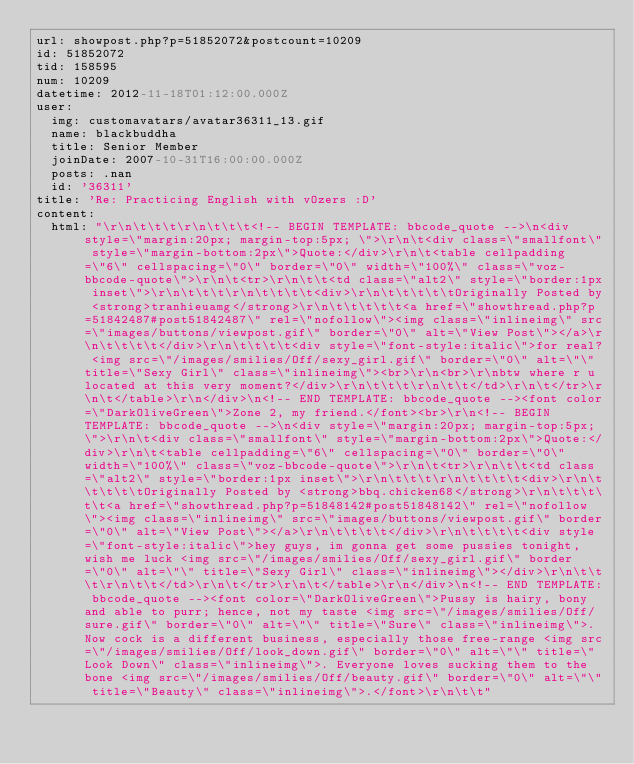<code> <loc_0><loc_0><loc_500><loc_500><_YAML_>url: showpost.php?p=51852072&postcount=10209
id: 51852072
tid: 158595
num: 10209
datetime: 2012-11-18T01:12:00.000Z
user:
  img: customavatars/avatar36311_13.gif
  name: blackbuddha
  title: Senior Member
  joinDate: 2007-10-31T16:00:00.000Z
  posts: .nan
  id: '36311'
title: 'Re: Practicing English with vOzers :D'
content:
  html: "\r\n\t\t\t\r\n\t\t\t<!-- BEGIN TEMPLATE: bbcode_quote -->\n<div style=\"margin:20px; margin-top:5px; \">\r\n\t<div class=\"smallfont\" style=\"margin-bottom:2px\">Quote:</div>\r\n\t<table cellpadding=\"6\" cellspacing=\"0\" border=\"0\" width=\"100%\" class=\"voz-bbcode-quote\">\r\n\t<tr>\r\n\t\t<td class=\"alt2\" style=\"border:1px inset\">\r\n\t\t\t\r\n\t\t\t\t<div>\r\n\t\t\t\t\tOriginally Posted by <strong>tranhieuamg</strong>\r\n\t\t\t\t\t<a href=\"showthread.php?p=51842487#post51842487\" rel=\"nofollow\"><img class=\"inlineimg\" src=\"images/buttons/viewpost.gif\" border=\"0\" alt=\"View Post\"></a>\r\n\t\t\t\t</div>\r\n\t\t\t\t<div style=\"font-style:italic\">for real? <img src=\"/images/smilies/Off/sexy_girl.gif\" border=\"0\" alt=\"\" title=\"Sexy Girl\" class=\"inlineimg\"><br>\r\n<br>\r\nbtw where r u located at this very moment?</div>\r\n\t\t\t\r\n\t\t</td>\r\n\t</tr>\r\n\t</table>\r\n</div>\n<!-- END TEMPLATE: bbcode_quote --><font color=\"DarkOliveGreen\">Zone 2, my friend.</font><br>\r\n<!-- BEGIN TEMPLATE: bbcode_quote -->\n<div style=\"margin:20px; margin-top:5px; \">\r\n\t<div class=\"smallfont\" style=\"margin-bottom:2px\">Quote:</div>\r\n\t<table cellpadding=\"6\" cellspacing=\"0\" border=\"0\" width=\"100%\" class=\"voz-bbcode-quote\">\r\n\t<tr>\r\n\t\t<td class=\"alt2\" style=\"border:1px inset\">\r\n\t\t\t\r\n\t\t\t\t<div>\r\n\t\t\t\t\tOriginally Posted by <strong>bbq.chicken68</strong>\r\n\t\t\t\t\t<a href=\"showthread.php?p=51848142#post51848142\" rel=\"nofollow\"><img class=\"inlineimg\" src=\"images/buttons/viewpost.gif\" border=\"0\" alt=\"View Post\"></a>\r\n\t\t\t\t</div>\r\n\t\t\t\t<div style=\"font-style:italic\">hey guys, im gonna get some pussies tonight, wish me luck <img src=\"/images/smilies/Off/sexy_girl.gif\" border=\"0\" alt=\"\" title=\"Sexy Girl\" class=\"inlineimg\"></div>\r\n\t\t\t\r\n\t\t</td>\r\n\t</tr>\r\n\t</table>\r\n</div>\n<!-- END TEMPLATE: bbcode_quote --><font color=\"DarkOliveGreen\">Pussy is hairy, bony and able to purr; hence, not my taste <img src=\"/images/smilies/Off/sure.gif\" border=\"0\" alt=\"\" title=\"Sure\" class=\"inlineimg\">. Now cock is a different business, especially those free-range <img src=\"/images/smilies/Off/look_down.gif\" border=\"0\" alt=\"\" title=\"Look Down\" class=\"inlineimg\">. Everyone loves sucking them to the bone <img src=\"/images/smilies/Off/beauty.gif\" border=\"0\" alt=\"\" title=\"Beauty\" class=\"inlineimg\">.</font>\r\n\t\t"</code> 